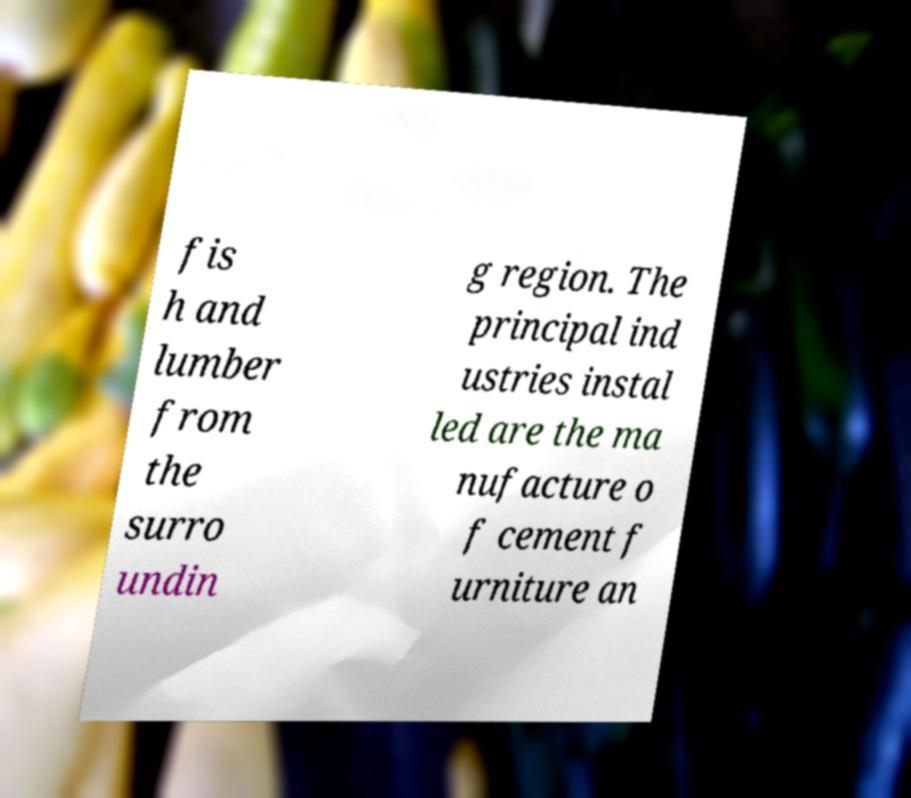Please identify and transcribe the text found in this image. fis h and lumber from the surro undin g region. The principal ind ustries instal led are the ma nufacture o f cement f urniture an 